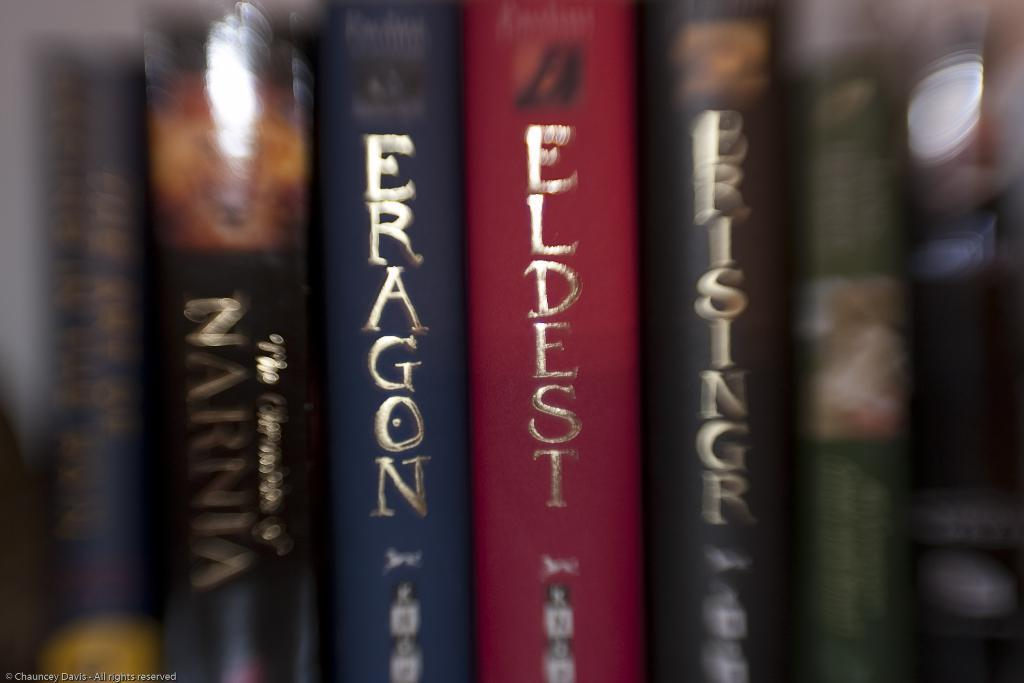<image>
Write a terse but informative summary of the picture. Books about eldest and eragon are lined up on a shelf 